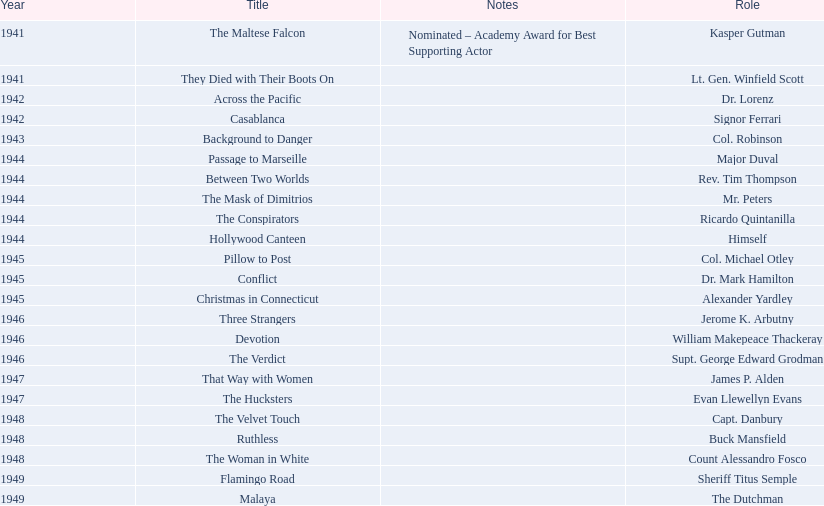What are the movies? The Maltese Falcon, They Died with Their Boots On, Across the Pacific, Casablanca, Background to Danger, Passage to Marseille, Between Two Worlds, The Mask of Dimitrios, The Conspirators, Hollywood Canteen, Pillow to Post, Conflict, Christmas in Connecticut, Three Strangers, Devotion, The Verdict, That Way with Women, The Hucksters, The Velvet Touch, Ruthless, The Woman in White, Flamingo Road, Malaya. Of these, for which did he get nominated for an oscar? The Maltese Falcon. 